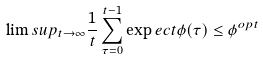<formula> <loc_0><loc_0><loc_500><loc_500>\lim s u p _ { t \rightarrow \infty } \frac { 1 } { t } \sum _ { \tau = 0 } ^ { t - 1 } \exp e c t { \phi ( \tau ) } \leq \phi ^ { o p t }</formula> 